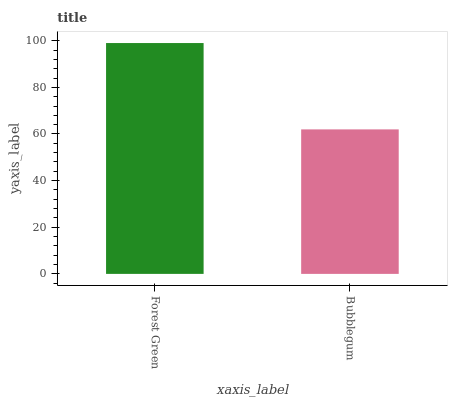Is Bubblegum the minimum?
Answer yes or no. Yes. Is Forest Green the maximum?
Answer yes or no. Yes. Is Bubblegum the maximum?
Answer yes or no. No. Is Forest Green greater than Bubblegum?
Answer yes or no. Yes. Is Bubblegum less than Forest Green?
Answer yes or no. Yes. Is Bubblegum greater than Forest Green?
Answer yes or no. No. Is Forest Green less than Bubblegum?
Answer yes or no. No. Is Forest Green the high median?
Answer yes or no. Yes. Is Bubblegum the low median?
Answer yes or no. Yes. Is Bubblegum the high median?
Answer yes or no. No. Is Forest Green the low median?
Answer yes or no. No. 